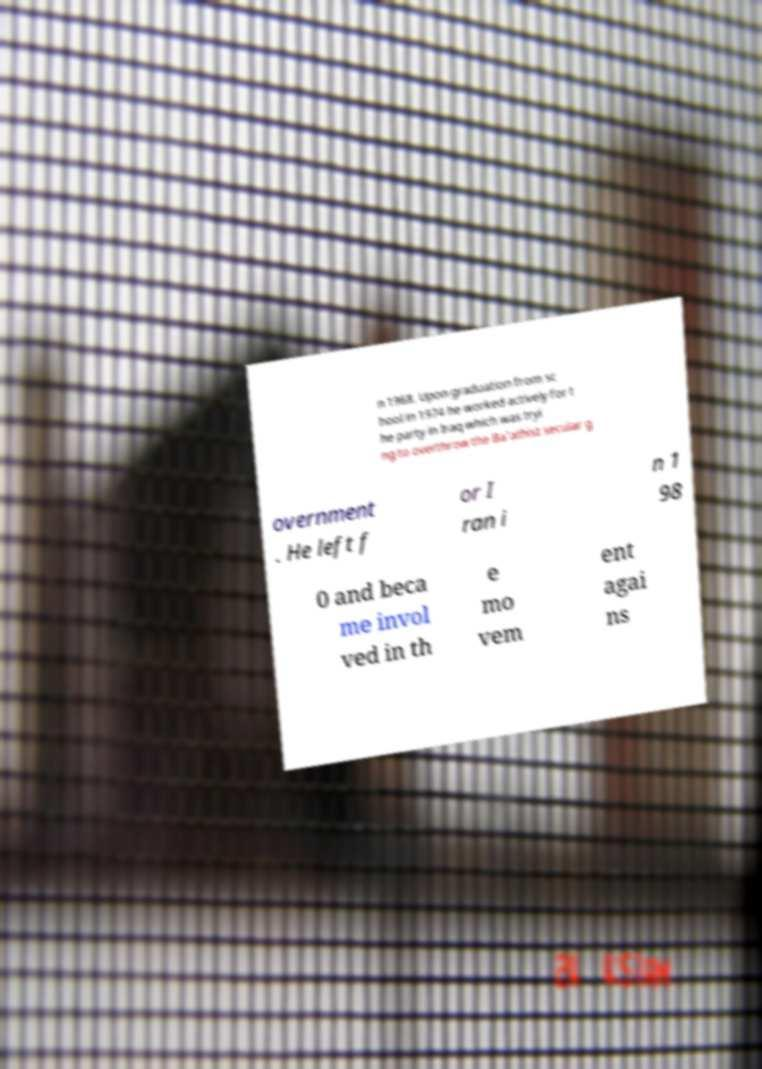Could you extract and type out the text from this image? n 1968. Upon graduation from sc hool in 1974 he worked actively for t he party in Iraq which was tryi ng to overthrow the Ba'athist secular g overnment . He left f or I ran i n 1 98 0 and beca me invol ved in th e mo vem ent agai ns 